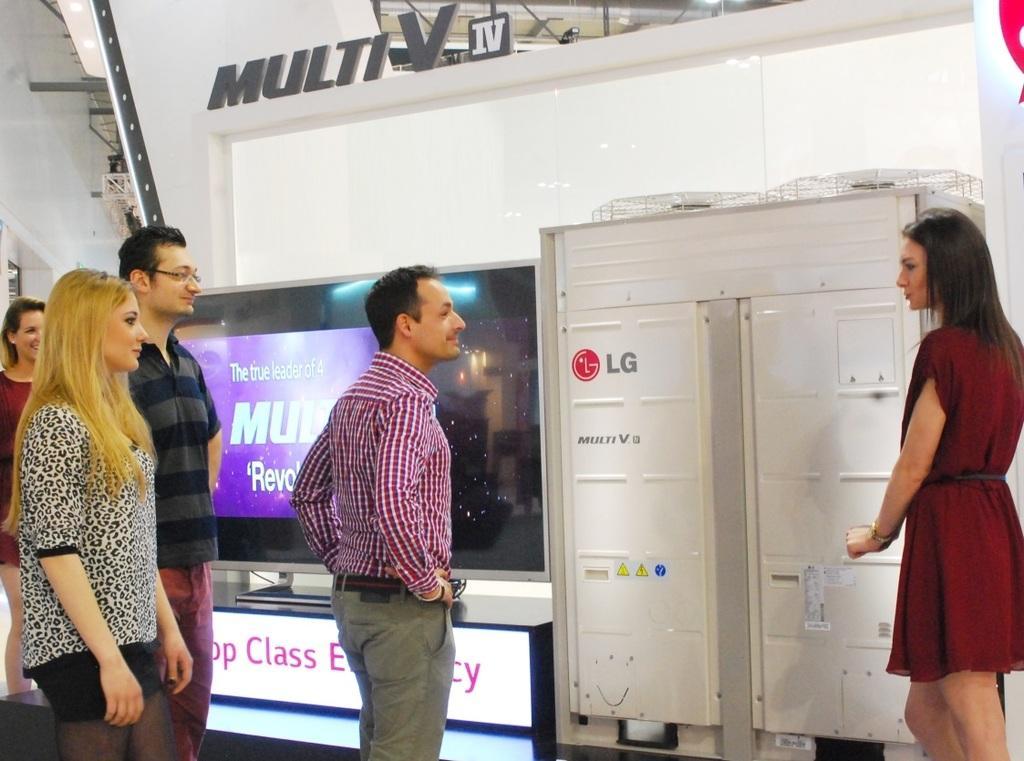Can you describe this image briefly? In the picture we can see group of people standing and on right side of the picture there is a woman wearing red color dress standing near the object and in the background of the picture there is Television and there is a wall. 